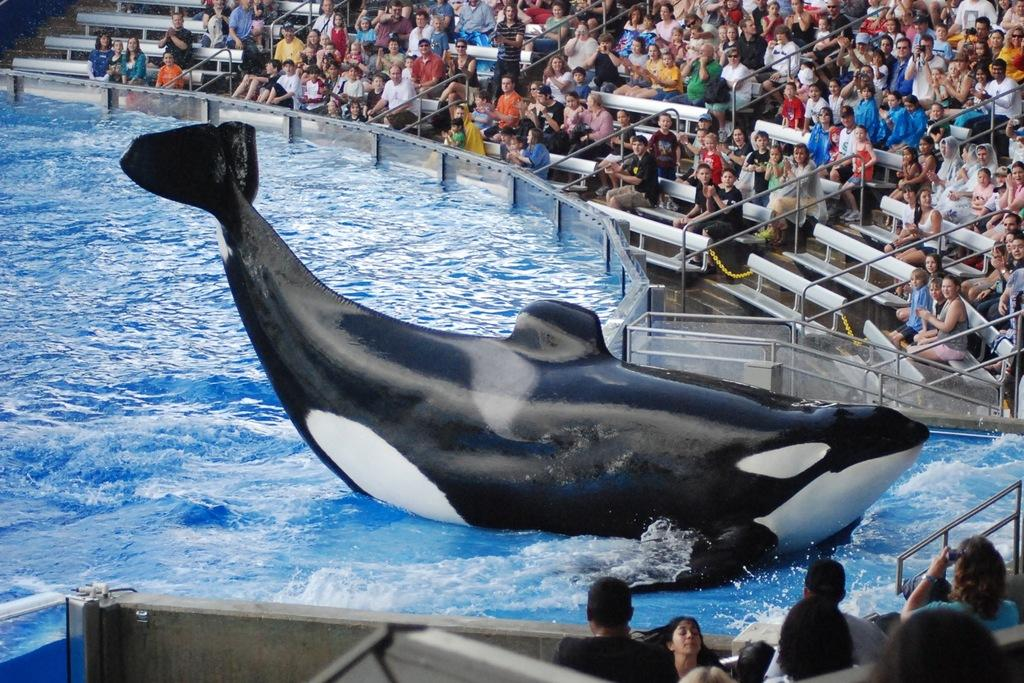What is the primary element in the image? There is water in the image. What can be seen in the water? There is a black artificial whale in the water. What are the people in the image doing? The people are sitting and watching the whale. Where is the faucet that controls the water flow in the image? There is no faucet present in the image; it is a natural body of water with an artificial whale. What force is being applied to the whale to make it move in the image? The whale is not moving in the image, and there is no force being applied to it. 